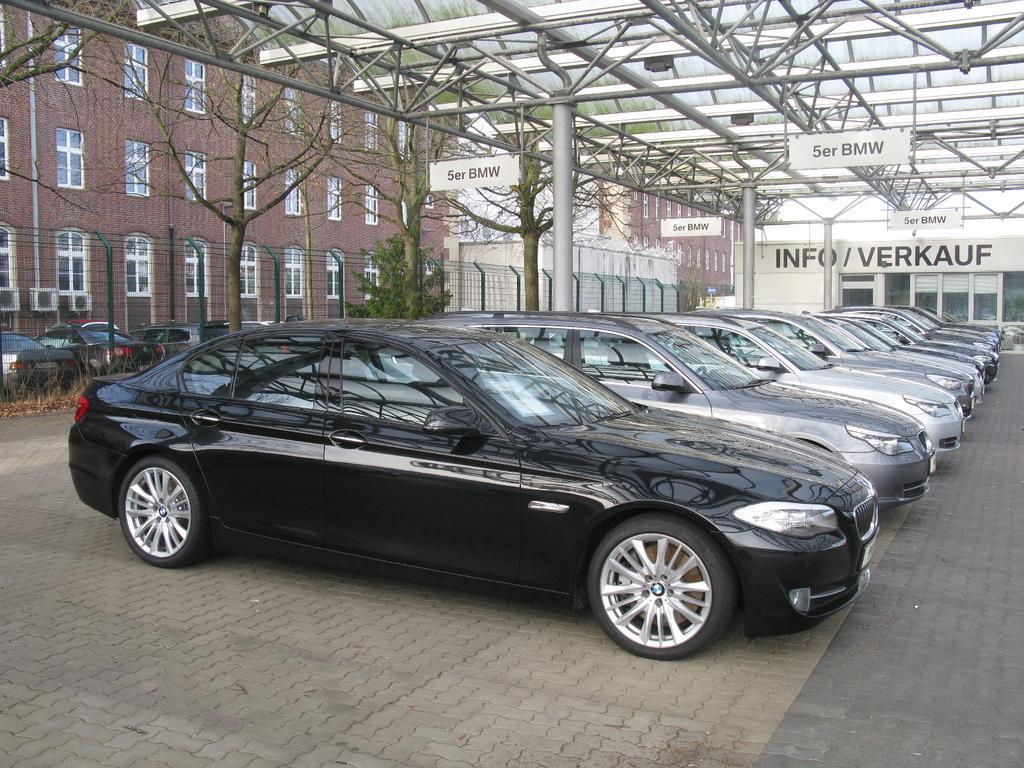How would you summarize this image in a sentence or two? In this image I can see many cars, they are black and gray color. Background I can see few other vehicles, railing, dried trees and I can see buildings in cream and brown color. 